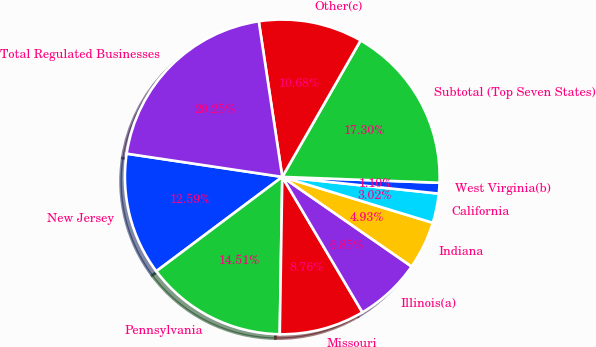<chart> <loc_0><loc_0><loc_500><loc_500><pie_chart><fcel>New Jersey<fcel>Pennsylvania<fcel>Missouri<fcel>Illinois(a)<fcel>Indiana<fcel>California<fcel>West Virginia(b)<fcel>Subtotal (Top Seven States)<fcel>Other(c)<fcel>Total Regulated Businesses<nl><fcel>12.59%<fcel>14.51%<fcel>8.76%<fcel>6.85%<fcel>4.93%<fcel>3.02%<fcel>1.1%<fcel>17.3%<fcel>10.68%<fcel>20.25%<nl></chart> 